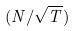<formula> <loc_0><loc_0><loc_500><loc_500>( N / \sqrt { T } )</formula> 